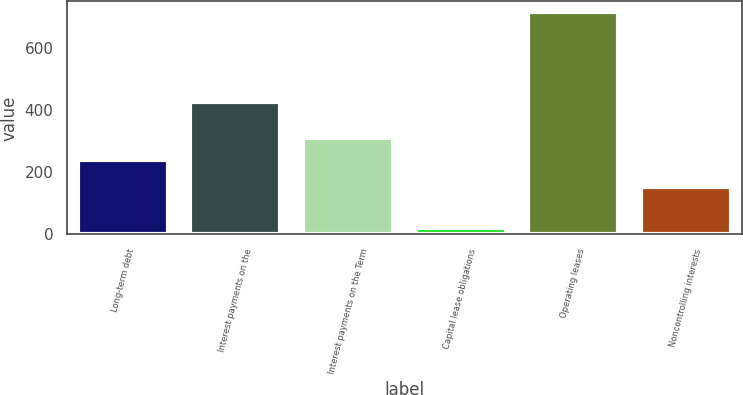Convert chart to OTSL. <chart><loc_0><loc_0><loc_500><loc_500><bar_chart><fcel>Long-term debt<fcel>Interest payments on the<fcel>Interest payments on the Term<fcel>Capital lease obligations<fcel>Operating leases<fcel>Noncontrolling interests<nl><fcel>240<fcel>426<fcel>309.4<fcel>21<fcel>715<fcel>152<nl></chart> 